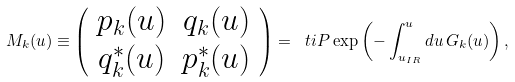Convert formula to latex. <formula><loc_0><loc_0><loc_500><loc_500>M _ { k } ( u ) \equiv \left ( \begin{array} { c c } p _ { k } ( u ) & q _ { k } ( u ) \\ q ^ { * } _ { k } ( u ) & p ^ { * } _ { k } ( u ) \end{array} \right ) = \ t i { P } \exp \left ( - \int ^ { u } _ { u _ { I R } } d u \, G _ { k } ( u ) \right ) ,</formula> 